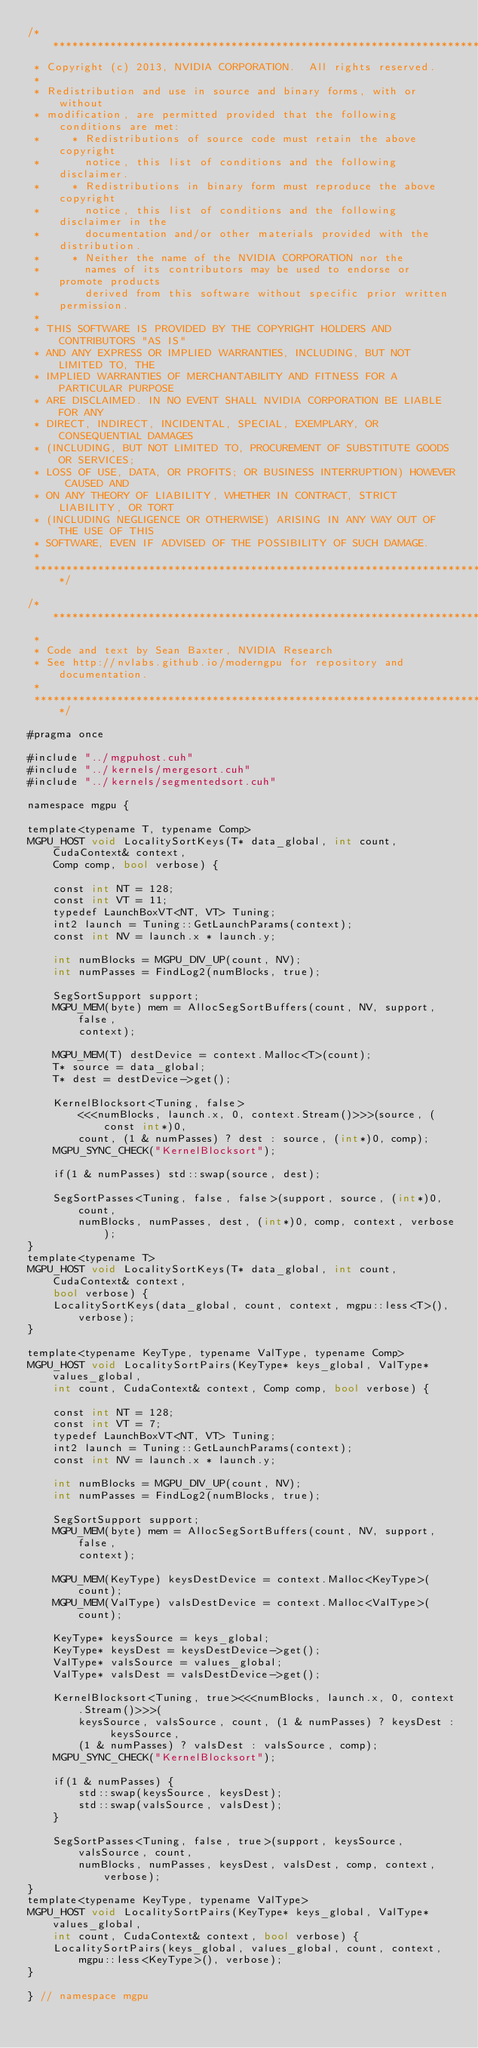<code> <loc_0><loc_0><loc_500><loc_500><_Cuda_>/******************************************************************************
 * Copyright (c) 2013, NVIDIA CORPORATION.  All rights reserved.
 * 
 * Redistribution and use in source and binary forms, with or without
 * modification, are permitted provided that the following conditions are met:
 *     * Redistributions of source code must retain the above copyright
 *       notice, this list of conditions and the following disclaimer.
 *     * Redistributions in binary form must reproduce the above copyright
 *       notice, this list of conditions and the following disclaimer in the
 *       documentation and/or other materials provided with the distribution.
 *     * Neither the name of the NVIDIA CORPORATION nor the
 *       names of its contributors may be used to endorse or promote products
 *       derived from this software without specific prior written permission.
 * 
 * THIS SOFTWARE IS PROVIDED BY THE COPYRIGHT HOLDERS AND CONTRIBUTORS "AS IS" 
 * AND ANY EXPRESS OR IMPLIED WARRANTIES, INCLUDING, BUT NOT LIMITED TO, THE
 * IMPLIED WARRANTIES OF MERCHANTABILITY AND FITNESS FOR A PARTICULAR PURPOSE 
 * ARE DISCLAIMED. IN NO EVENT SHALL NVIDIA CORPORATION BE LIABLE FOR ANY
 * DIRECT, INDIRECT, INCIDENTAL, SPECIAL, EXEMPLARY, OR CONSEQUENTIAL DAMAGES
 * (INCLUDING, BUT NOT LIMITED TO, PROCUREMENT OF SUBSTITUTE GOODS OR SERVICES;
 * LOSS OF USE, DATA, OR PROFITS; OR BUSINESS INTERRUPTION) HOWEVER CAUSED AND
 * ON ANY THEORY OF LIABILITY, WHETHER IN CONTRACT, STRICT LIABILITY, OR TORT
 * (INCLUDING NEGLIGENCE OR OTHERWISE) ARISING IN ANY WAY OUT OF THE USE OF THIS
 * SOFTWARE, EVEN IF ADVISED OF THE POSSIBILITY OF SUCH DAMAGE.
 *
 ******************************************************************************/

/******************************************************************************
 *
 * Code and text by Sean Baxter, NVIDIA Research
 * See http://nvlabs.github.io/moderngpu for repository and documentation.
 *
 ******************************************************************************/

#pragma once

#include "../mgpuhost.cuh"
#include "../kernels/mergesort.cuh"
#include "../kernels/segmentedsort.cuh"

namespace mgpu {

template<typename T, typename Comp>
MGPU_HOST void LocalitySortKeys(T* data_global, int count, CudaContext& context,
	Comp comp, bool verbose) {

	const int NT = 128;
	const int VT = 11;
	typedef LaunchBoxVT<NT, VT> Tuning;
	int2 launch = Tuning::GetLaunchParams(context);
	const int NV = launch.x * launch.y;

	int numBlocks = MGPU_DIV_UP(count, NV);
	int numPasses = FindLog2(numBlocks, true);

	SegSortSupport support;
	MGPU_MEM(byte) mem = AllocSegSortBuffers(count, NV, support, false,
		context);
	
	MGPU_MEM(T) destDevice = context.Malloc<T>(count);
	T* source = data_global;
	T* dest = destDevice->get(); 
	
	KernelBlocksort<Tuning, false>
		<<<numBlocks, launch.x, 0, context.Stream()>>>(source, (const int*)0,
		count, (1 & numPasses) ? dest : source, (int*)0, comp);
	MGPU_SYNC_CHECK("KernelBlocksort");

	if(1 & numPasses) std::swap(source, dest);

	SegSortPasses<Tuning, false, false>(support, source, (int*)0, count, 
		numBlocks, numPasses, dest, (int*)0, comp, context, verbose);
} 
template<typename T>
MGPU_HOST void LocalitySortKeys(T* data_global, int count, CudaContext& context,
	bool verbose) {
	LocalitySortKeys(data_global, count, context, mgpu::less<T>(), verbose);
}

template<typename KeyType, typename ValType, typename Comp>
MGPU_HOST void LocalitySortPairs(KeyType* keys_global, ValType* values_global,
	int count, CudaContext& context, Comp comp, bool verbose) {

	const int NT = 128;
	const int VT = 7;
	typedef LaunchBoxVT<NT, VT> Tuning;
	int2 launch = Tuning::GetLaunchParams(context);
	const int NV = launch.x * launch.y;

	int numBlocks = MGPU_DIV_UP(count, NV);
	int numPasses = FindLog2(numBlocks, true);

	SegSortSupport support;
	MGPU_MEM(byte) mem = AllocSegSortBuffers(count, NV, support, false,
		context);
	
	MGPU_MEM(KeyType) keysDestDevice = context.Malloc<KeyType>(count);
	MGPU_MEM(ValType) valsDestDevice = context.Malloc<ValType>(count);

	KeyType* keysSource = keys_global;
	KeyType* keysDest = keysDestDevice->get();
	ValType* valsSource = values_global;
	ValType* valsDest = valsDestDevice->get();

	KernelBlocksort<Tuning, true><<<numBlocks, launch.x, 0, context.Stream()>>>(
		keysSource, valsSource, count, (1 & numPasses) ? keysDest : keysSource,
		(1 & numPasses) ? valsDest : valsSource, comp);
	MGPU_SYNC_CHECK("KernelBlocksort");

	if(1 & numPasses) {
		std::swap(keysSource, keysDest);
		std::swap(valsSource, valsDest);
	}

	SegSortPasses<Tuning, false, true>(support, keysSource, valsSource, count,
		numBlocks, numPasses, keysDest, valsDest, comp, context, verbose);
} 
template<typename KeyType, typename ValType>
MGPU_HOST void LocalitySortPairs(KeyType* keys_global, ValType* values_global,
	int count, CudaContext& context, bool verbose) {
	LocalitySortPairs(keys_global, values_global, count, context,
		mgpu::less<KeyType>(), verbose);
}

} // namespace mgpu
</code> 